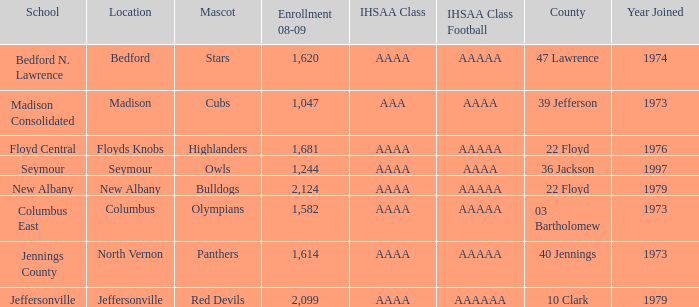What's the IHSAA Class when the school is Seymour? AAAA. 